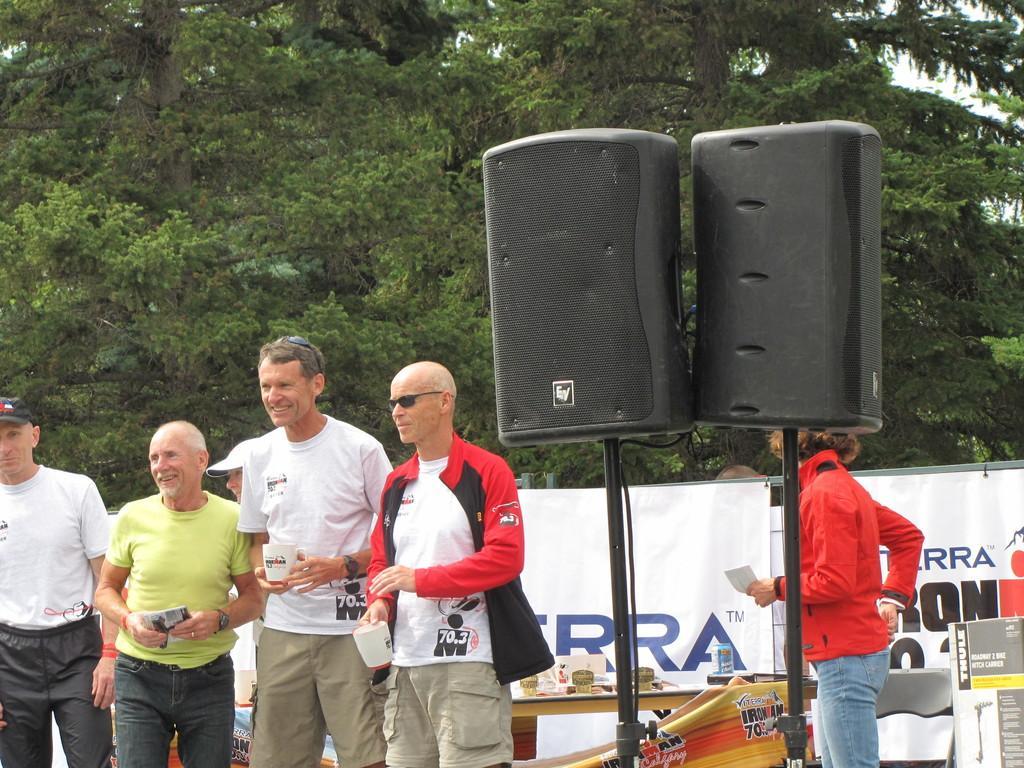In one or two sentences, can you explain what this image depicts? In this image there are two speakers in the middle. Beside the speakers there are two men who are holding the cups. In the background there are trees. In the background there is a banner. In front of the banner there is a table on which there are cards. On the right side there is a person who is standing beside the chair. On the left side there are two persons who are standing by holding the cards. 